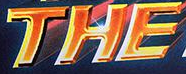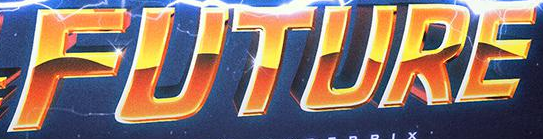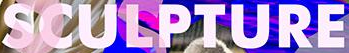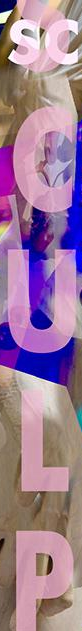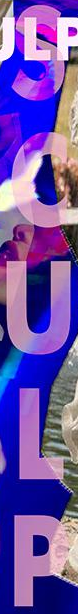What words can you see in these images in sequence, separated by a semicolon? THE; FUTURE; SCULPTURE; SCULP; SCULP 